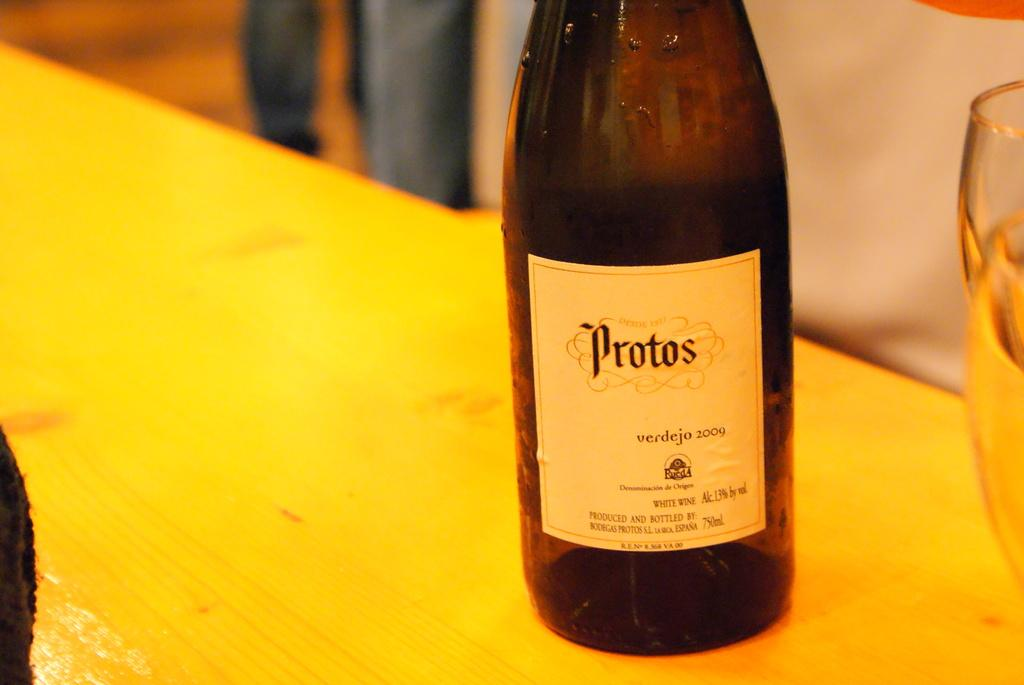What is the main object in the picture? There is a bottle in the picture. How is the bottle being emphasized in the image? The bottle is highlighted. Where is the bottle located? The bottle is on a table. What is attached to the bottle? There is a sticker on the bottle. Can you describe the background of the image? The background of the image is blurry. What other objects are near the bottle? There are glasses beside the bottle. What type of van is parked next to the bottle in the image? There is no van present in the image; it only features a bottle, glasses, and a blurry background. How old is the daughter of the person who owns the bottle in the image? There is no mention of a daughter or a person owning the bottle in the image. 